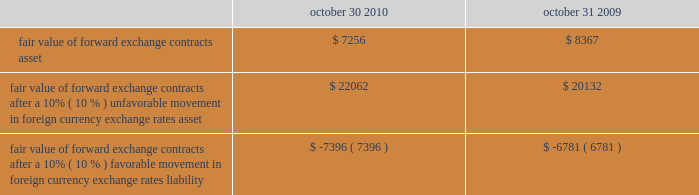The table illustrates the effect that a 10% ( 10 % ) unfavorable or favorable movement in foreign currency exchange rates , relative to the u.s .
Dollar , would have on the fair value of our forward exchange contracts as of october 30 , 2010 and october 31 , 2009: .
Fair value of forward exchange contracts after a 10% ( 10 % ) unfavorable movement in foreign currency exchange rates asset .
$ 22062 $ 20132 fair value of forward exchange contracts after a 10% ( 10 % ) favorable movement in foreign currency exchange rates liability .
$ ( 7396 ) $ ( 6781 ) the calculation assumes that each exchange rate would change in the same direction relative to the u.s .
Dollar .
In addition to the direct effects of changes in exchange rates , such changes typically affect the volume of sales or the foreign currency sales price as competitors 2019 products become more or less attractive .
Our sensitivity analysis of the effects of changes in foreign currency exchange rates does not factor in a potential change in sales levels or local currency selling prices. .
What is the growth rate in the fair value of forward exchange contracts asset from 2009 to 2010? 
Computations: ((7256 - 8367) / 8367)
Answer: -0.13278. 